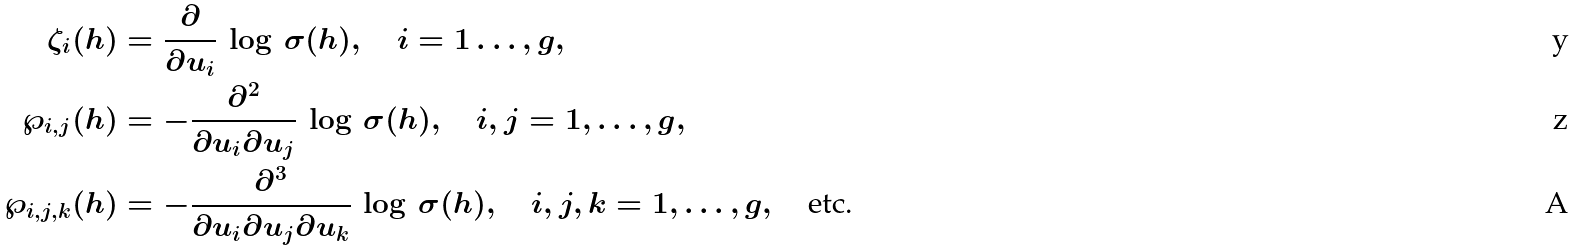Convert formula to latex. <formula><loc_0><loc_0><loc_500><loc_500>\zeta _ { i } ( h ) & = \frac { \partial } { \partial u _ { i } } \, \log \, \sigma ( h ) , \quad i = 1 \dots , g , \\ \wp _ { i , j } ( h ) & = - \frac { \partial ^ { 2 } } { \partial u _ { i } \partial u _ { j } } \, \log \, \sigma ( h ) , \quad i , j = 1 , \dots , g , \\ \wp _ { i , j , k } ( h ) & = - \frac { \partial ^ { 3 } } { \partial u _ { i } \partial u _ { j } \partial u _ { k } } \, \log \, \sigma ( h ) , \quad i , j , k = 1 , \dots , g , \quad \text {etc.}</formula> 